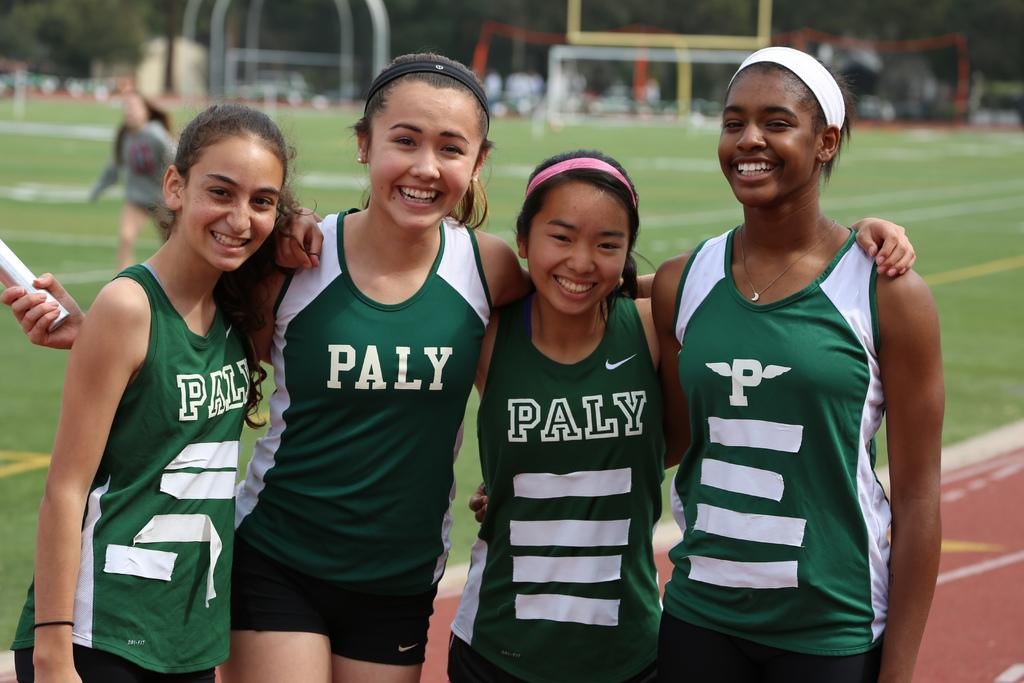<image>
Present a compact description of the photo's key features. Four girls wearing "PALY" jerseys posing for a photo. 